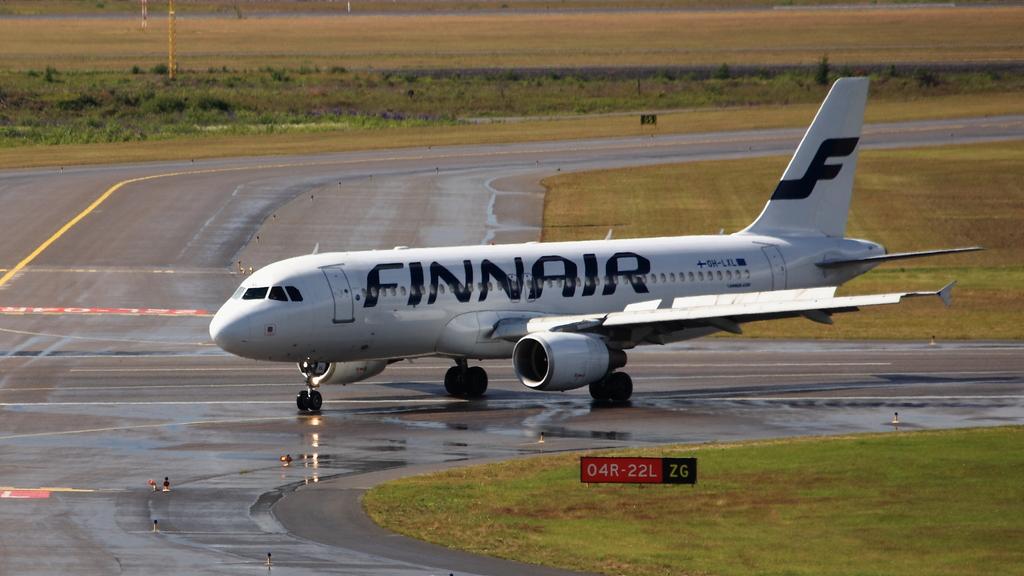What airline does this plane belong to?
Make the answer very short. Finnair. Where does finnair fly to?
Your answer should be compact. Unanswerable. 